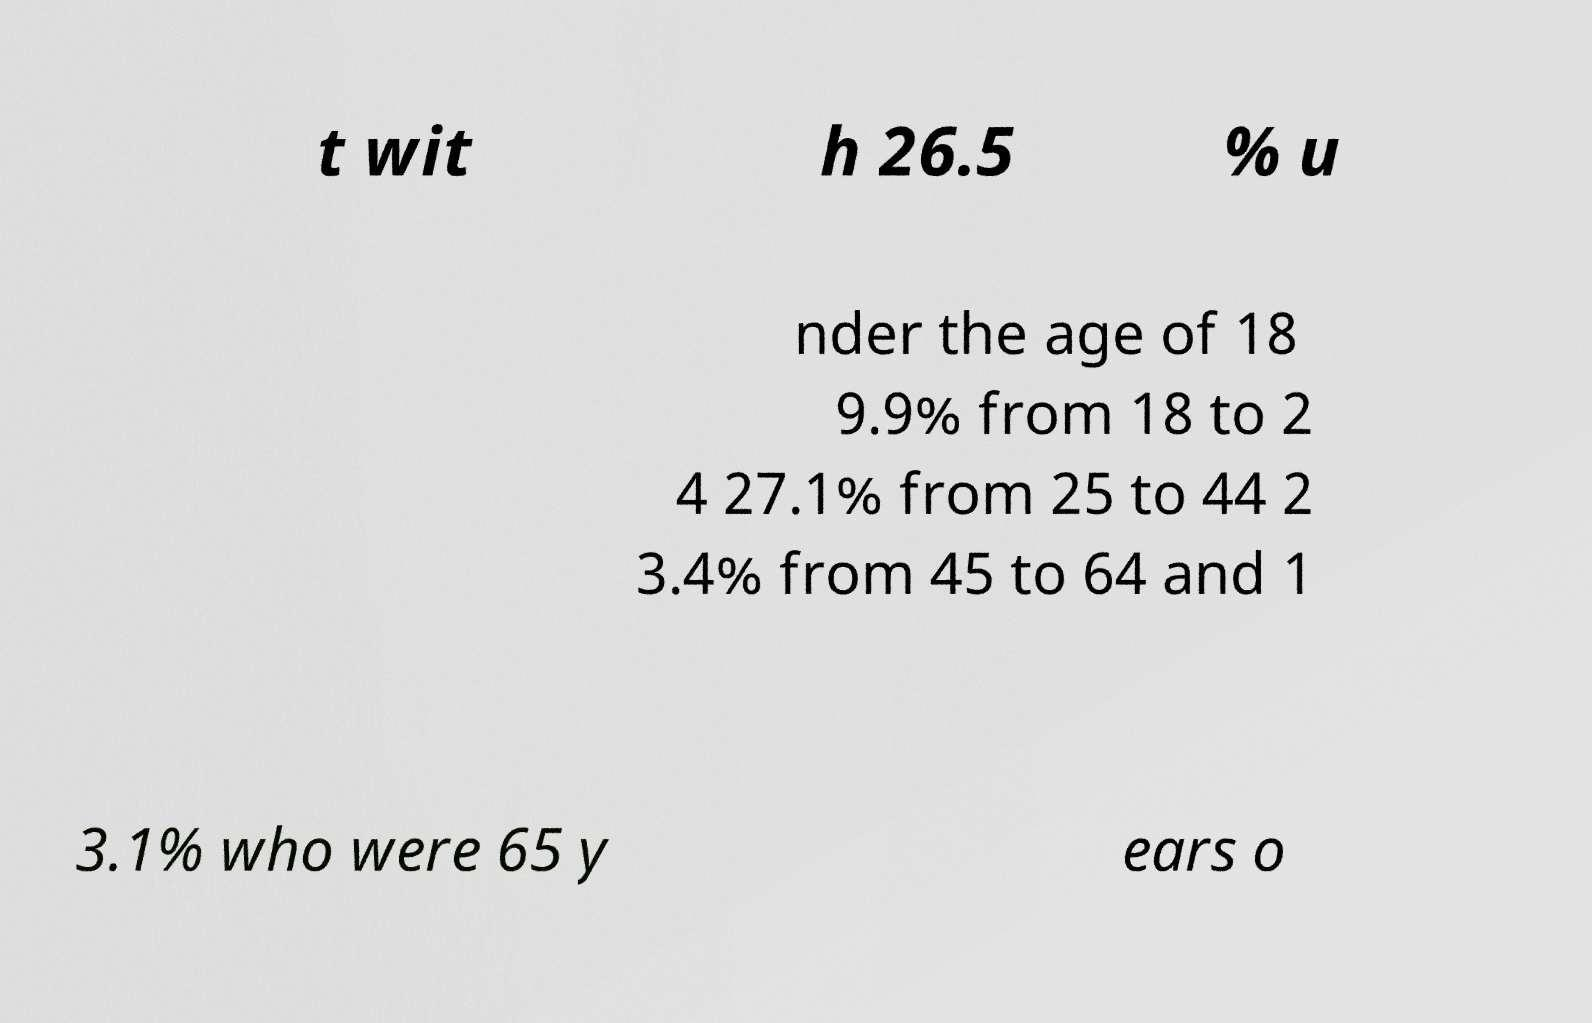For documentation purposes, I need the text within this image transcribed. Could you provide that? t wit h 26.5 % u nder the age of 18 9.9% from 18 to 2 4 27.1% from 25 to 44 2 3.4% from 45 to 64 and 1 3.1% who were 65 y ears o 